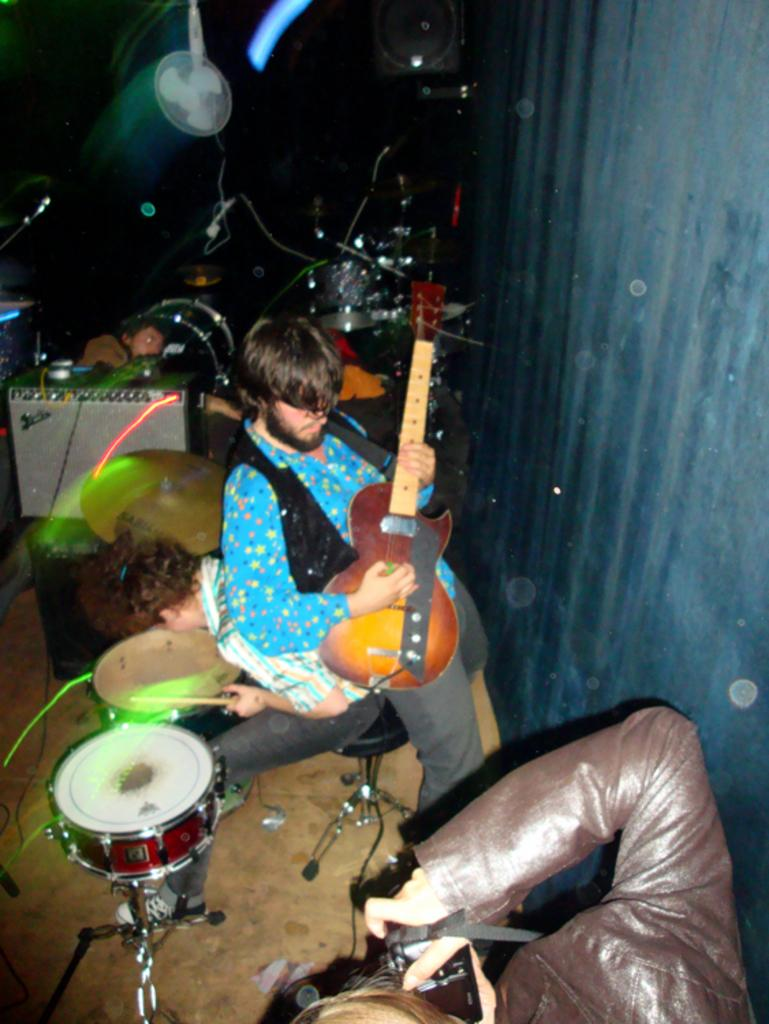What is the man in the image doing? The man is standing and playing a guitar. What is the person with the camera doing? The person is holding a camera and taking a picture. What is the person seated doing? The person is seated and playing drums. What type of silk is being used to play the guitar in the image? There is no silk present in the image, and the guitar is being played with the man's hands, not silk. 